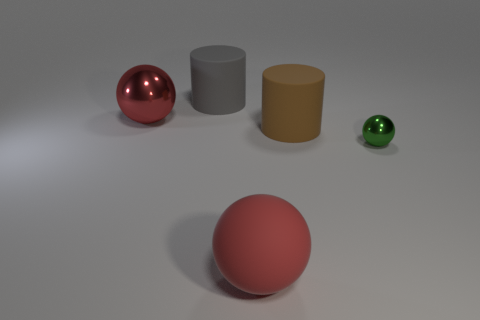Are there any other things that have the same size as the green metallic sphere?
Ensure brevity in your answer.  No. The thing that is the same color as the rubber sphere is what size?
Offer a terse response. Large. What color is the large metal ball?
Your response must be concise. Red. There is a thing to the right of the large brown matte cylinder; what is its shape?
Your answer should be very brief. Sphere. What number of gray things are tiny shiny spheres or rubber spheres?
Offer a very short reply. 0. What is the color of the large cylinder that is the same material as the large gray object?
Make the answer very short. Brown. Does the small thing have the same color as the rubber thing behind the big red metallic ball?
Keep it short and to the point. No. What is the color of the object that is both to the right of the large red matte object and in front of the large brown rubber thing?
Keep it short and to the point. Green. There is a small shiny sphere; how many objects are behind it?
Provide a short and direct response. 3. How many objects are either green metallic objects or things that are in front of the large red metallic object?
Keep it short and to the point. 3. 